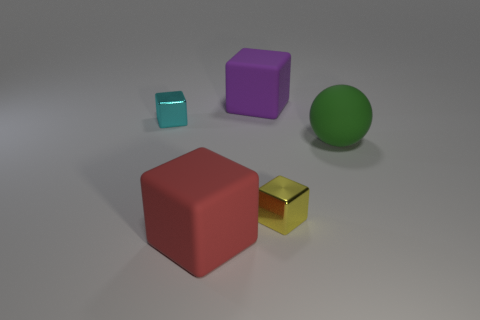How many red blocks are the same size as the red rubber thing?
Ensure brevity in your answer.  0. How many big matte things are in front of the big cube that is in front of the cube that is to the left of the red rubber cube?
Make the answer very short. 0. How many objects are both to the left of the purple rubber thing and behind the big sphere?
Offer a terse response. 1. Are there any other things of the same color as the ball?
Provide a short and direct response. No. How many rubber things are cyan things or tiny cubes?
Your answer should be very brief. 0. The large cube behind the big object that is on the left side of the large block that is behind the big green rubber thing is made of what material?
Make the answer very short. Rubber. There is a purple object left of the metallic thing in front of the large sphere; what is its material?
Give a very brief answer. Rubber. Do the shiny object on the left side of the big red cube and the rubber thing in front of the large rubber ball have the same size?
Provide a short and direct response. No. Are there any other things that are made of the same material as the large ball?
Provide a short and direct response. Yes. How many big things are green matte balls or rubber things?
Your response must be concise. 3. 